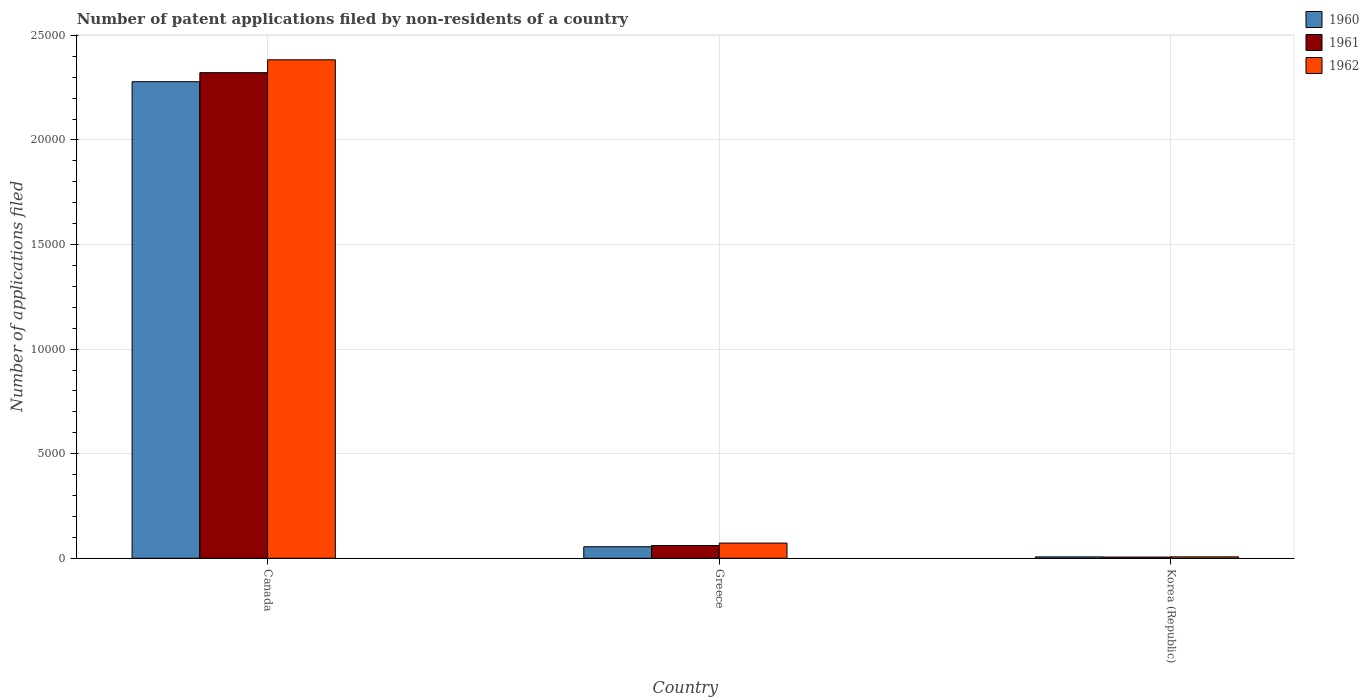How many different coloured bars are there?
Ensure brevity in your answer.  3. What is the label of the 1st group of bars from the left?
Give a very brief answer. Canada. In how many cases, is the number of bars for a given country not equal to the number of legend labels?
Ensure brevity in your answer.  0. Across all countries, what is the maximum number of applications filed in 1962?
Your response must be concise. 2.38e+04. In which country was the number of applications filed in 1960 maximum?
Provide a succinct answer. Canada. In which country was the number of applications filed in 1960 minimum?
Provide a short and direct response. Korea (Republic). What is the total number of applications filed in 1960 in the graph?
Your answer should be compact. 2.34e+04. What is the difference between the number of applications filed in 1961 in Greece and that in Korea (Republic)?
Provide a succinct answer. 551. What is the difference between the number of applications filed in 1961 in Greece and the number of applications filed in 1960 in Canada?
Offer a very short reply. -2.22e+04. What is the average number of applications filed in 1960 per country?
Your answer should be very brief. 7801. What is the difference between the number of applications filed of/in 1960 and number of applications filed of/in 1962 in Canada?
Offer a very short reply. -1048. What is the ratio of the number of applications filed in 1962 in Canada to that in Greece?
Ensure brevity in your answer.  32.83. Is the number of applications filed in 1961 in Canada less than that in Korea (Republic)?
Your answer should be very brief. No. What is the difference between the highest and the second highest number of applications filed in 1960?
Provide a succinct answer. 2.27e+04. What is the difference between the highest and the lowest number of applications filed in 1962?
Make the answer very short. 2.38e+04. What does the 2nd bar from the right in Korea (Republic) represents?
Offer a terse response. 1961. What is the difference between two consecutive major ticks on the Y-axis?
Your response must be concise. 5000. How many legend labels are there?
Keep it short and to the point. 3. How are the legend labels stacked?
Provide a short and direct response. Vertical. What is the title of the graph?
Keep it short and to the point. Number of patent applications filed by non-residents of a country. What is the label or title of the Y-axis?
Provide a short and direct response. Number of applications filed. What is the Number of applications filed in 1960 in Canada?
Make the answer very short. 2.28e+04. What is the Number of applications filed in 1961 in Canada?
Provide a succinct answer. 2.32e+04. What is the Number of applications filed in 1962 in Canada?
Your response must be concise. 2.38e+04. What is the Number of applications filed of 1960 in Greece?
Give a very brief answer. 551. What is the Number of applications filed of 1961 in Greece?
Your answer should be compact. 609. What is the Number of applications filed in 1962 in Greece?
Your response must be concise. 726. What is the Number of applications filed in 1960 in Korea (Republic)?
Give a very brief answer. 66. What is the Number of applications filed in 1961 in Korea (Republic)?
Keep it short and to the point. 58. Across all countries, what is the maximum Number of applications filed of 1960?
Make the answer very short. 2.28e+04. Across all countries, what is the maximum Number of applications filed in 1961?
Your answer should be compact. 2.32e+04. Across all countries, what is the maximum Number of applications filed of 1962?
Offer a terse response. 2.38e+04. Across all countries, what is the minimum Number of applications filed of 1960?
Your answer should be very brief. 66. What is the total Number of applications filed in 1960 in the graph?
Your answer should be compact. 2.34e+04. What is the total Number of applications filed of 1961 in the graph?
Keep it short and to the point. 2.39e+04. What is the total Number of applications filed in 1962 in the graph?
Your response must be concise. 2.46e+04. What is the difference between the Number of applications filed of 1960 in Canada and that in Greece?
Provide a succinct answer. 2.22e+04. What is the difference between the Number of applications filed of 1961 in Canada and that in Greece?
Your response must be concise. 2.26e+04. What is the difference between the Number of applications filed of 1962 in Canada and that in Greece?
Your answer should be very brief. 2.31e+04. What is the difference between the Number of applications filed in 1960 in Canada and that in Korea (Republic)?
Ensure brevity in your answer.  2.27e+04. What is the difference between the Number of applications filed of 1961 in Canada and that in Korea (Republic)?
Provide a short and direct response. 2.32e+04. What is the difference between the Number of applications filed in 1962 in Canada and that in Korea (Republic)?
Your answer should be very brief. 2.38e+04. What is the difference between the Number of applications filed of 1960 in Greece and that in Korea (Republic)?
Your answer should be very brief. 485. What is the difference between the Number of applications filed of 1961 in Greece and that in Korea (Republic)?
Your answer should be compact. 551. What is the difference between the Number of applications filed in 1962 in Greece and that in Korea (Republic)?
Your answer should be very brief. 658. What is the difference between the Number of applications filed of 1960 in Canada and the Number of applications filed of 1961 in Greece?
Offer a very short reply. 2.22e+04. What is the difference between the Number of applications filed of 1960 in Canada and the Number of applications filed of 1962 in Greece?
Your answer should be very brief. 2.21e+04. What is the difference between the Number of applications filed of 1961 in Canada and the Number of applications filed of 1962 in Greece?
Your answer should be compact. 2.25e+04. What is the difference between the Number of applications filed in 1960 in Canada and the Number of applications filed in 1961 in Korea (Republic)?
Your answer should be compact. 2.27e+04. What is the difference between the Number of applications filed in 1960 in Canada and the Number of applications filed in 1962 in Korea (Republic)?
Keep it short and to the point. 2.27e+04. What is the difference between the Number of applications filed in 1961 in Canada and the Number of applications filed in 1962 in Korea (Republic)?
Ensure brevity in your answer.  2.32e+04. What is the difference between the Number of applications filed in 1960 in Greece and the Number of applications filed in 1961 in Korea (Republic)?
Offer a terse response. 493. What is the difference between the Number of applications filed of 1960 in Greece and the Number of applications filed of 1962 in Korea (Republic)?
Give a very brief answer. 483. What is the difference between the Number of applications filed in 1961 in Greece and the Number of applications filed in 1962 in Korea (Republic)?
Your answer should be compact. 541. What is the average Number of applications filed of 1960 per country?
Make the answer very short. 7801. What is the average Number of applications filed of 1961 per country?
Keep it short and to the point. 7962. What is the average Number of applications filed in 1962 per country?
Your answer should be very brief. 8209.33. What is the difference between the Number of applications filed in 1960 and Number of applications filed in 1961 in Canada?
Keep it short and to the point. -433. What is the difference between the Number of applications filed of 1960 and Number of applications filed of 1962 in Canada?
Ensure brevity in your answer.  -1048. What is the difference between the Number of applications filed of 1961 and Number of applications filed of 1962 in Canada?
Provide a succinct answer. -615. What is the difference between the Number of applications filed of 1960 and Number of applications filed of 1961 in Greece?
Offer a very short reply. -58. What is the difference between the Number of applications filed in 1960 and Number of applications filed in 1962 in Greece?
Provide a succinct answer. -175. What is the difference between the Number of applications filed in 1961 and Number of applications filed in 1962 in Greece?
Offer a very short reply. -117. What is the difference between the Number of applications filed of 1961 and Number of applications filed of 1962 in Korea (Republic)?
Your answer should be compact. -10. What is the ratio of the Number of applications filed in 1960 in Canada to that in Greece?
Provide a short and direct response. 41.35. What is the ratio of the Number of applications filed in 1961 in Canada to that in Greece?
Offer a terse response. 38.13. What is the ratio of the Number of applications filed of 1962 in Canada to that in Greece?
Ensure brevity in your answer.  32.83. What is the ratio of the Number of applications filed in 1960 in Canada to that in Korea (Republic)?
Make the answer very short. 345.24. What is the ratio of the Number of applications filed in 1961 in Canada to that in Korea (Republic)?
Keep it short and to the point. 400.33. What is the ratio of the Number of applications filed in 1962 in Canada to that in Korea (Republic)?
Offer a terse response. 350.5. What is the ratio of the Number of applications filed of 1960 in Greece to that in Korea (Republic)?
Your response must be concise. 8.35. What is the ratio of the Number of applications filed in 1961 in Greece to that in Korea (Republic)?
Make the answer very short. 10.5. What is the ratio of the Number of applications filed in 1962 in Greece to that in Korea (Republic)?
Ensure brevity in your answer.  10.68. What is the difference between the highest and the second highest Number of applications filed in 1960?
Keep it short and to the point. 2.22e+04. What is the difference between the highest and the second highest Number of applications filed of 1961?
Provide a short and direct response. 2.26e+04. What is the difference between the highest and the second highest Number of applications filed of 1962?
Your answer should be compact. 2.31e+04. What is the difference between the highest and the lowest Number of applications filed in 1960?
Give a very brief answer. 2.27e+04. What is the difference between the highest and the lowest Number of applications filed in 1961?
Provide a short and direct response. 2.32e+04. What is the difference between the highest and the lowest Number of applications filed in 1962?
Keep it short and to the point. 2.38e+04. 